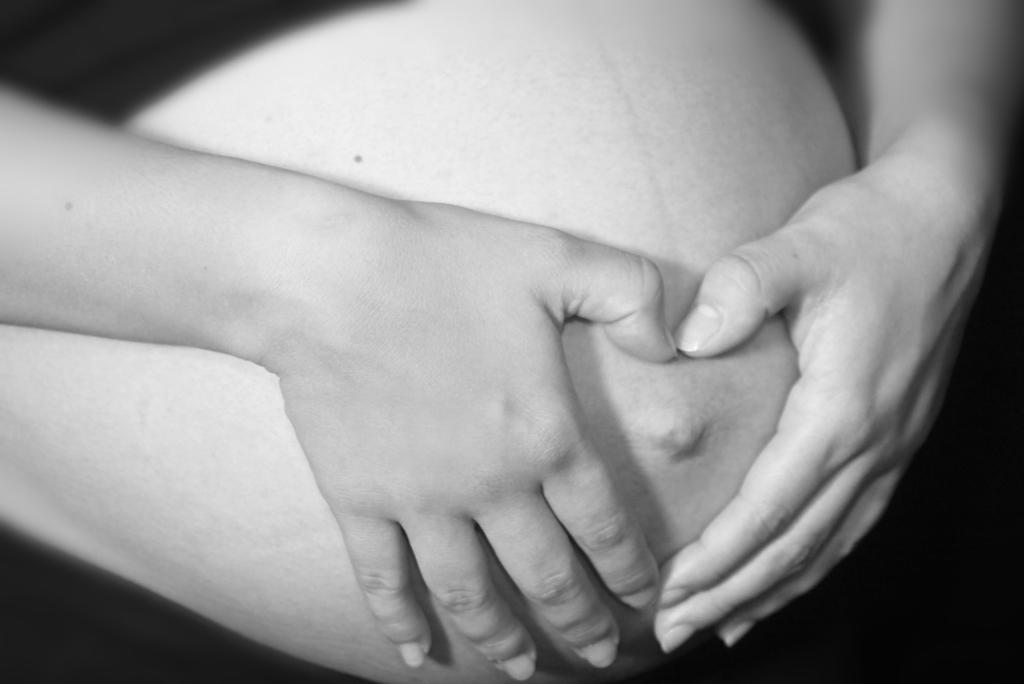What is the main subject of the image? The main subject of the image is a person. What is the person doing in the image? The person is touching their belly with their hands. What type of apparatus is the person using to touch their belly in the image? There is no apparatus present in the image; the person is using their hands to touch their belly. Can you see a pot in the image? There is no pot present in the image. Is there a cow visible in the image? There is no cow present in the image. 